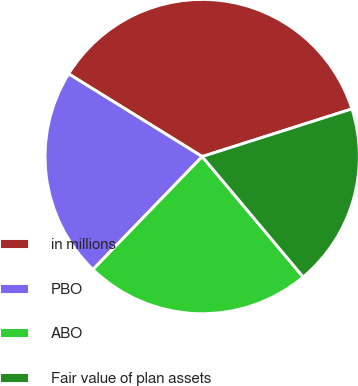Convert chart to OTSL. <chart><loc_0><loc_0><loc_500><loc_500><pie_chart><fcel>in millions<fcel>PBO<fcel>ABO<fcel>Fair value of plan assets<nl><fcel>36.27%<fcel>21.59%<fcel>23.34%<fcel>18.8%<nl></chart> 